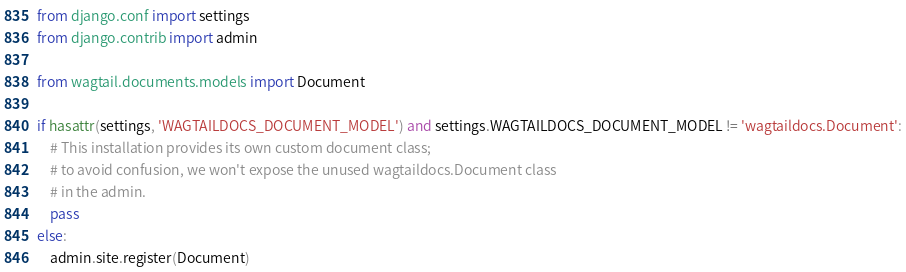Convert code to text. <code><loc_0><loc_0><loc_500><loc_500><_Python_>from django.conf import settings
from django.contrib import admin

from wagtail.documents.models import Document

if hasattr(settings, 'WAGTAILDOCS_DOCUMENT_MODEL') and settings.WAGTAILDOCS_DOCUMENT_MODEL != 'wagtaildocs.Document':
    # This installation provides its own custom document class;
    # to avoid confusion, we won't expose the unused wagtaildocs.Document class
    # in the admin.
    pass
else:
    admin.site.register(Document)
</code> 